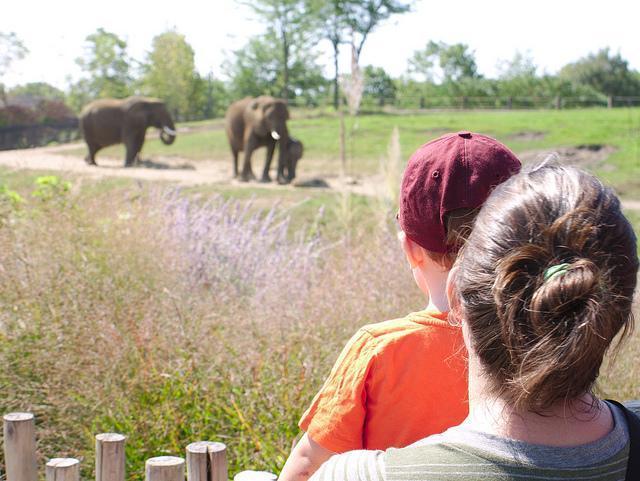How many elephants are there?
Give a very brief answer. 2. How many people can you see?
Give a very brief answer. 2. 